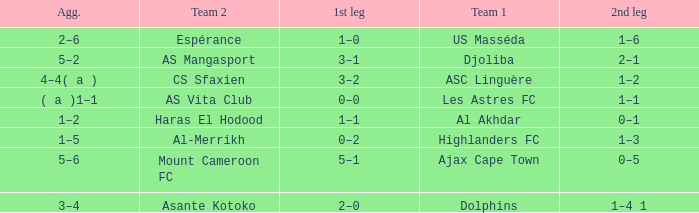What is the team 1 with team 2 Mount Cameroon FC? Ajax Cape Town. 